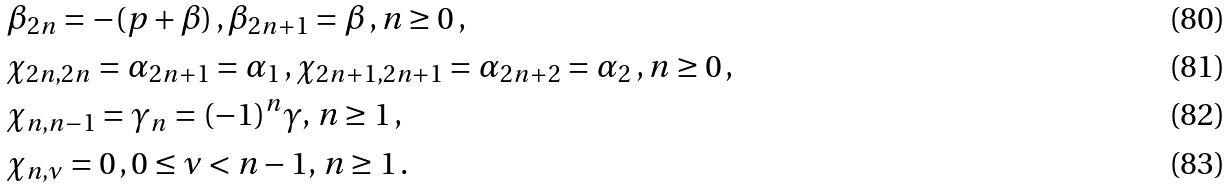<formula> <loc_0><loc_0><loc_500><loc_500>& \beta _ { 2 n } = - ( p + \beta ) \, , \beta _ { 2 n + 1 } = \beta \, , n \geq 0 \, , \\ & \chi _ { 2 n , 2 n } = \alpha _ { 2 n + 1 } = \alpha _ { 1 } \, , \chi _ { 2 n + 1 , 2 n + 1 } = \alpha _ { 2 n + 2 } = \alpha _ { 2 } \, , n \geq 0 \, , \\ & \chi _ { n , n - 1 } = \gamma _ { n } = ( - 1 ) ^ { n } \gamma , \, n \geq 1 \, , \\ & \chi _ { n , \nu } = 0 \, , 0 \leq \nu < n - 1 , \, n \geq 1 \, .</formula> 